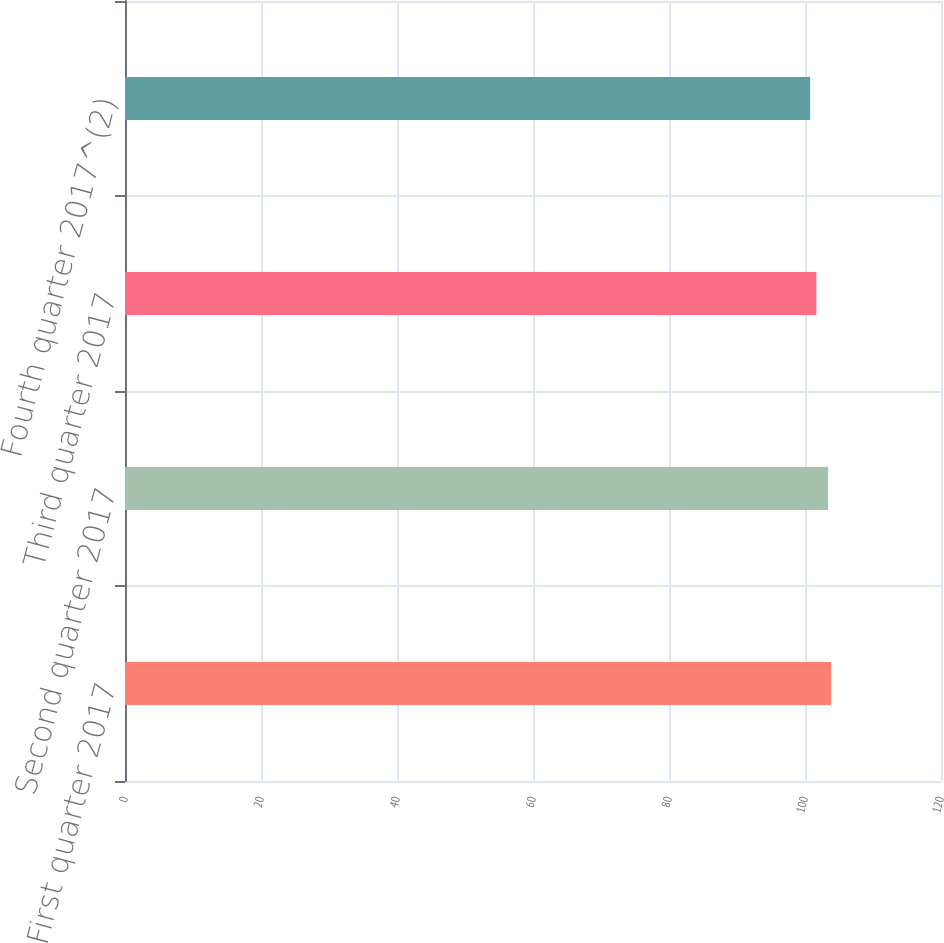Convert chart. <chart><loc_0><loc_0><loc_500><loc_500><bar_chart><fcel>First quarter 2017<fcel>Second quarter 2017<fcel>Third quarter 2017<fcel>Fourth quarter 2017^(2)<nl><fcel>103.84<fcel>103.4<fcel>101.67<fcel>100.76<nl></chart> 